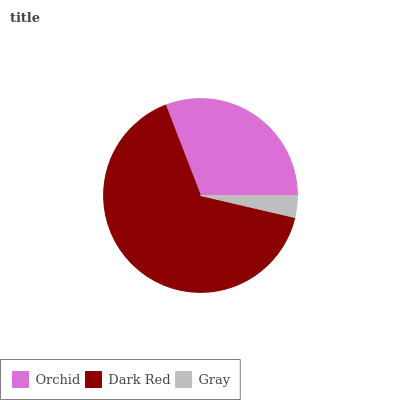Is Gray the minimum?
Answer yes or no. Yes. Is Dark Red the maximum?
Answer yes or no. Yes. Is Dark Red the minimum?
Answer yes or no. No. Is Gray the maximum?
Answer yes or no. No. Is Dark Red greater than Gray?
Answer yes or no. Yes. Is Gray less than Dark Red?
Answer yes or no. Yes. Is Gray greater than Dark Red?
Answer yes or no. No. Is Dark Red less than Gray?
Answer yes or no. No. Is Orchid the high median?
Answer yes or no. Yes. Is Orchid the low median?
Answer yes or no. Yes. Is Gray the high median?
Answer yes or no. No. Is Dark Red the low median?
Answer yes or no. No. 